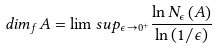Convert formula to latex. <formula><loc_0><loc_0><loc_500><loc_500>d i m _ { f } A = \lim s u p _ { \epsilon \rightarrow 0 ^ { + } } \frac { \ln N _ { \epsilon } \left ( A \right ) } { \ln \left ( 1 / \epsilon \right ) }</formula> 